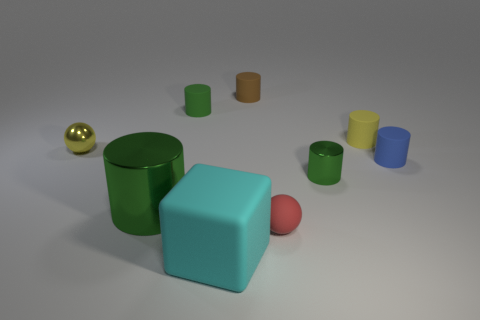Subtract all cyan cubes. How many green cylinders are left? 3 Subtract all tiny green cylinders. How many cylinders are left? 4 Subtract 4 cylinders. How many cylinders are left? 2 Subtract all green cylinders. How many cylinders are left? 3 Subtract all blue cylinders. Subtract all red balls. How many cylinders are left? 5 Subtract all spheres. How many objects are left? 7 Add 1 gray things. How many gray things exist? 1 Subtract 0 blue cubes. How many objects are left? 9 Subtract all small cyan metallic things. Subtract all small shiny spheres. How many objects are left? 8 Add 8 yellow shiny objects. How many yellow shiny objects are left? 9 